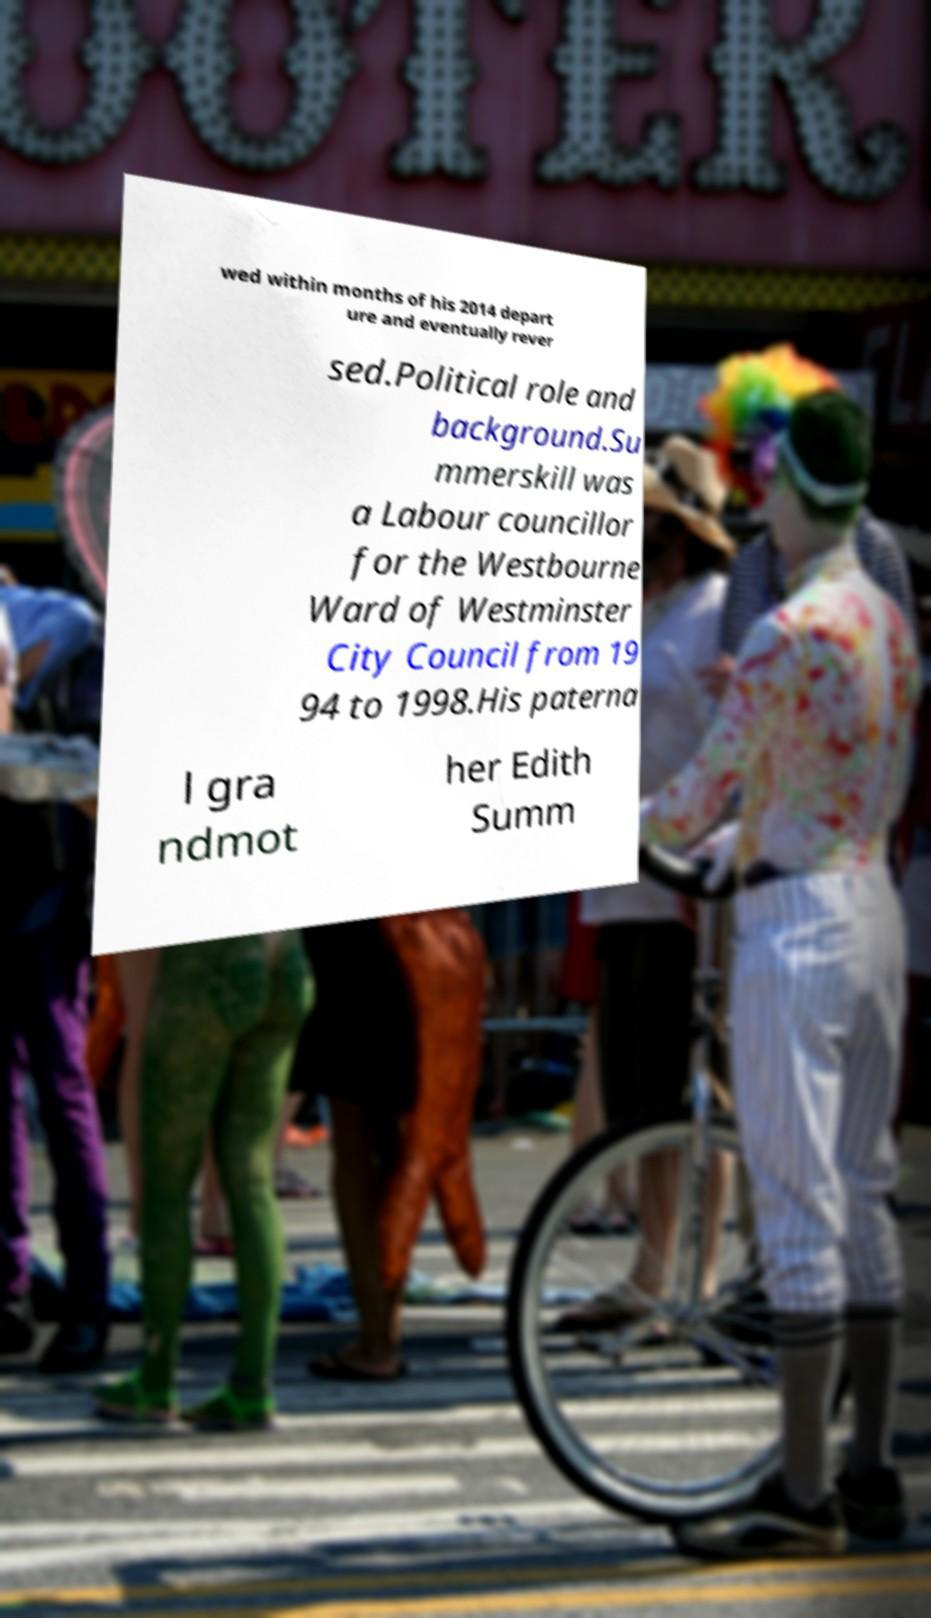I need the written content from this picture converted into text. Can you do that? wed within months of his 2014 depart ure and eventually rever sed.Political role and background.Su mmerskill was a Labour councillor for the Westbourne Ward of Westminster City Council from 19 94 to 1998.His paterna l gra ndmot her Edith Summ 